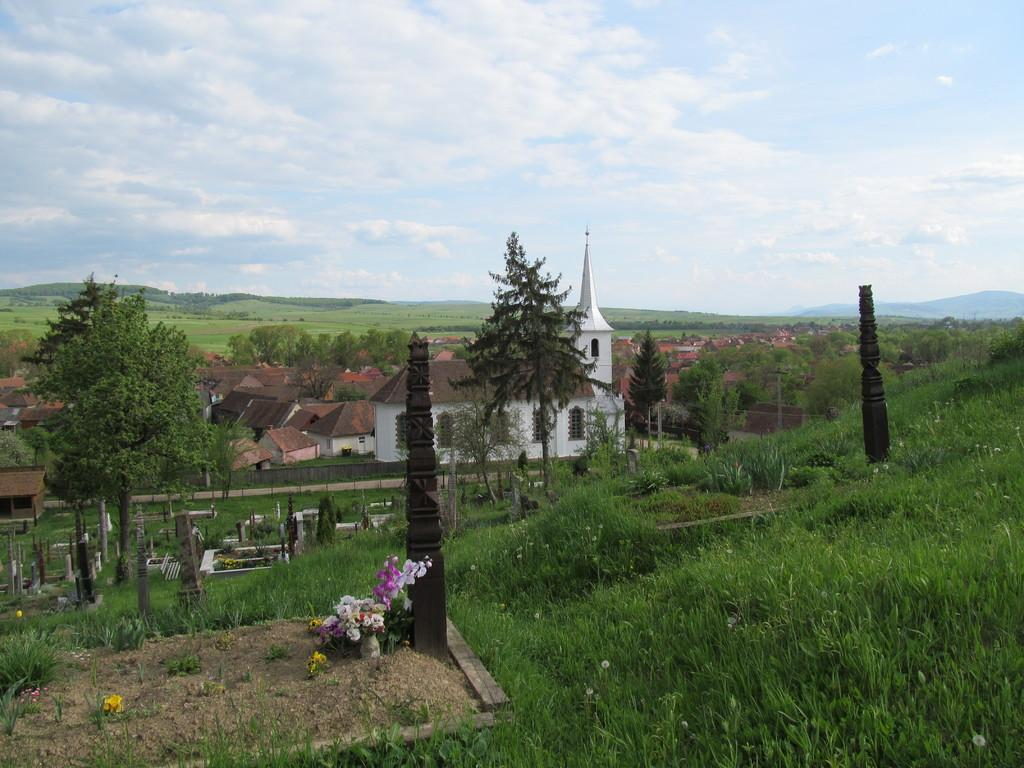What type of structures can be seen in the image? There are many houses in the image. What features do the houses have? The houses have windows. What type of vegetation is present in the image? There are many trees and grass in the image. What type of objects can be seen in the image? There are headstones and a bokeh on the ground. What is the condition of the sky in the image? The sky is cloudy. What decision is being made in the library in the image? There is no library present in the image, and therefore no decision-making can be observed. 